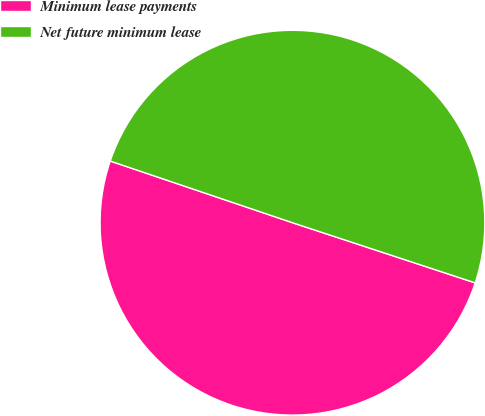Convert chart to OTSL. <chart><loc_0><loc_0><loc_500><loc_500><pie_chart><fcel>Minimum lease payments<fcel>Net future minimum lease<nl><fcel>50.13%<fcel>49.87%<nl></chart> 